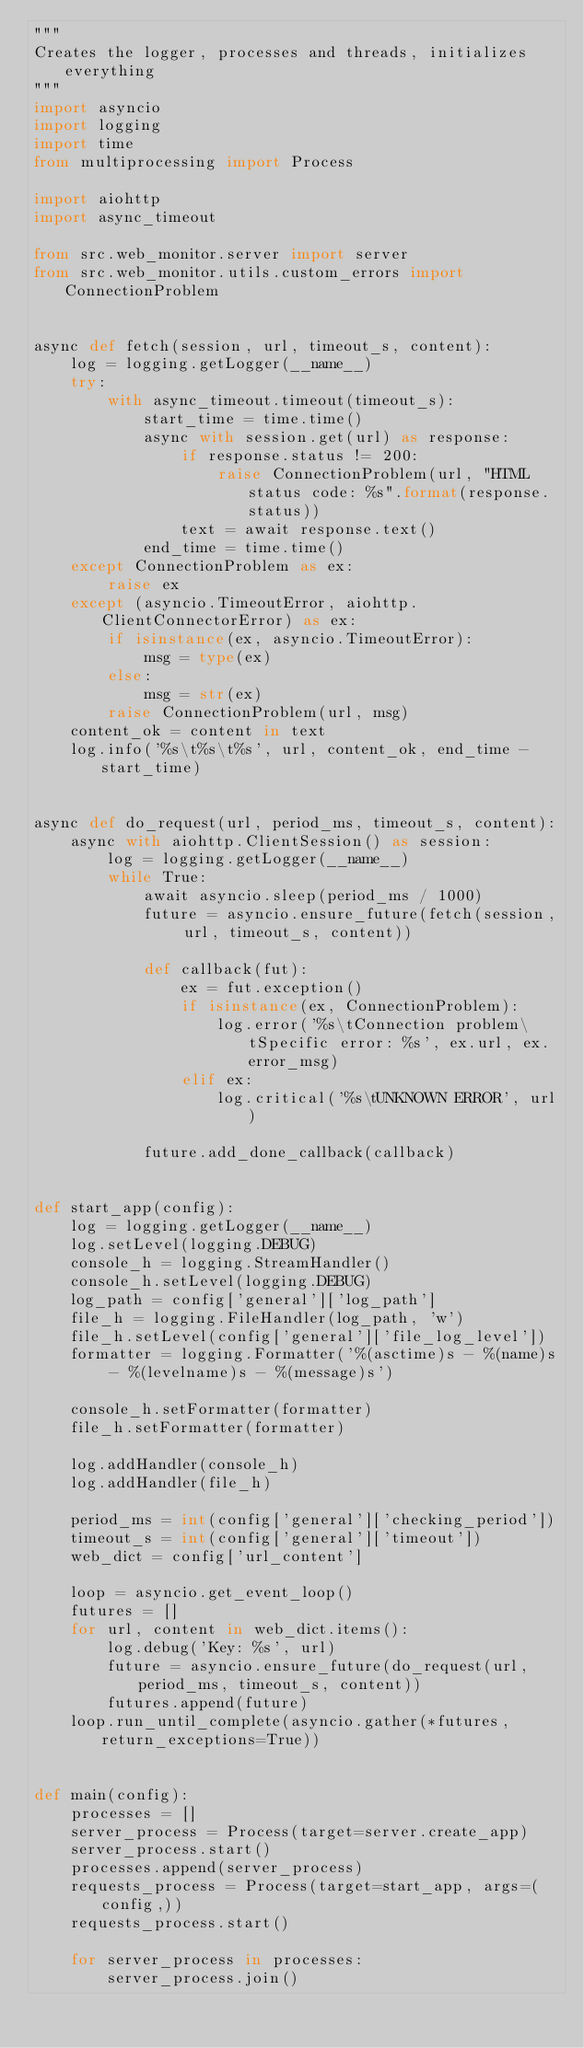Convert code to text. <code><loc_0><loc_0><loc_500><loc_500><_Python_>"""
Creates the logger, processes and threads, initializes everything
"""
import asyncio
import logging
import time
from multiprocessing import Process

import aiohttp
import async_timeout

from src.web_monitor.server import server
from src.web_monitor.utils.custom_errors import ConnectionProblem


async def fetch(session, url, timeout_s, content):
    log = logging.getLogger(__name__)
    try:
        with async_timeout.timeout(timeout_s):
            start_time = time.time()
            async with session.get(url) as response:
                if response.status != 200:
                    raise ConnectionProblem(url, "HTML status code: %s".format(response.status))
                text = await response.text()
            end_time = time.time()
    except ConnectionProblem as ex:
        raise ex
    except (asyncio.TimeoutError, aiohttp.ClientConnectorError) as ex:
        if isinstance(ex, asyncio.TimeoutError):
            msg = type(ex)
        else:
            msg = str(ex)
        raise ConnectionProblem(url, msg)
    content_ok = content in text
    log.info('%s\t%s\t%s', url, content_ok, end_time - start_time)


async def do_request(url, period_ms, timeout_s, content):
    async with aiohttp.ClientSession() as session:
        log = logging.getLogger(__name__)
        while True:
            await asyncio.sleep(period_ms / 1000)
            future = asyncio.ensure_future(fetch(session, url, timeout_s, content))

            def callback(fut):
                ex = fut.exception()
                if isinstance(ex, ConnectionProblem):
                    log.error('%s\tConnection problem\tSpecific error: %s', ex.url, ex.error_msg)
                elif ex:
                    log.critical('%s\tUNKNOWN ERROR', url)

            future.add_done_callback(callback)


def start_app(config):
    log = logging.getLogger(__name__)
    log.setLevel(logging.DEBUG)
    console_h = logging.StreamHandler()
    console_h.setLevel(logging.DEBUG)
    log_path = config['general']['log_path']
    file_h = logging.FileHandler(log_path, 'w')
    file_h.setLevel(config['general']['file_log_level'])
    formatter = logging.Formatter('%(asctime)s - %(name)s - %(levelname)s - %(message)s')

    console_h.setFormatter(formatter)
    file_h.setFormatter(formatter)

    log.addHandler(console_h)
    log.addHandler(file_h)

    period_ms = int(config['general']['checking_period'])
    timeout_s = int(config['general']['timeout'])
    web_dict = config['url_content']

    loop = asyncio.get_event_loop()
    futures = []
    for url, content in web_dict.items():
        log.debug('Key: %s', url)
        future = asyncio.ensure_future(do_request(url, period_ms, timeout_s, content))
        futures.append(future)
    loop.run_until_complete(asyncio.gather(*futures, return_exceptions=True))


def main(config):
    processes = []
    server_process = Process(target=server.create_app)
    server_process.start()
    processes.append(server_process)
    requests_process = Process(target=start_app, args=(config,))
    requests_process.start()

    for server_process in processes:
        server_process.join()
</code> 